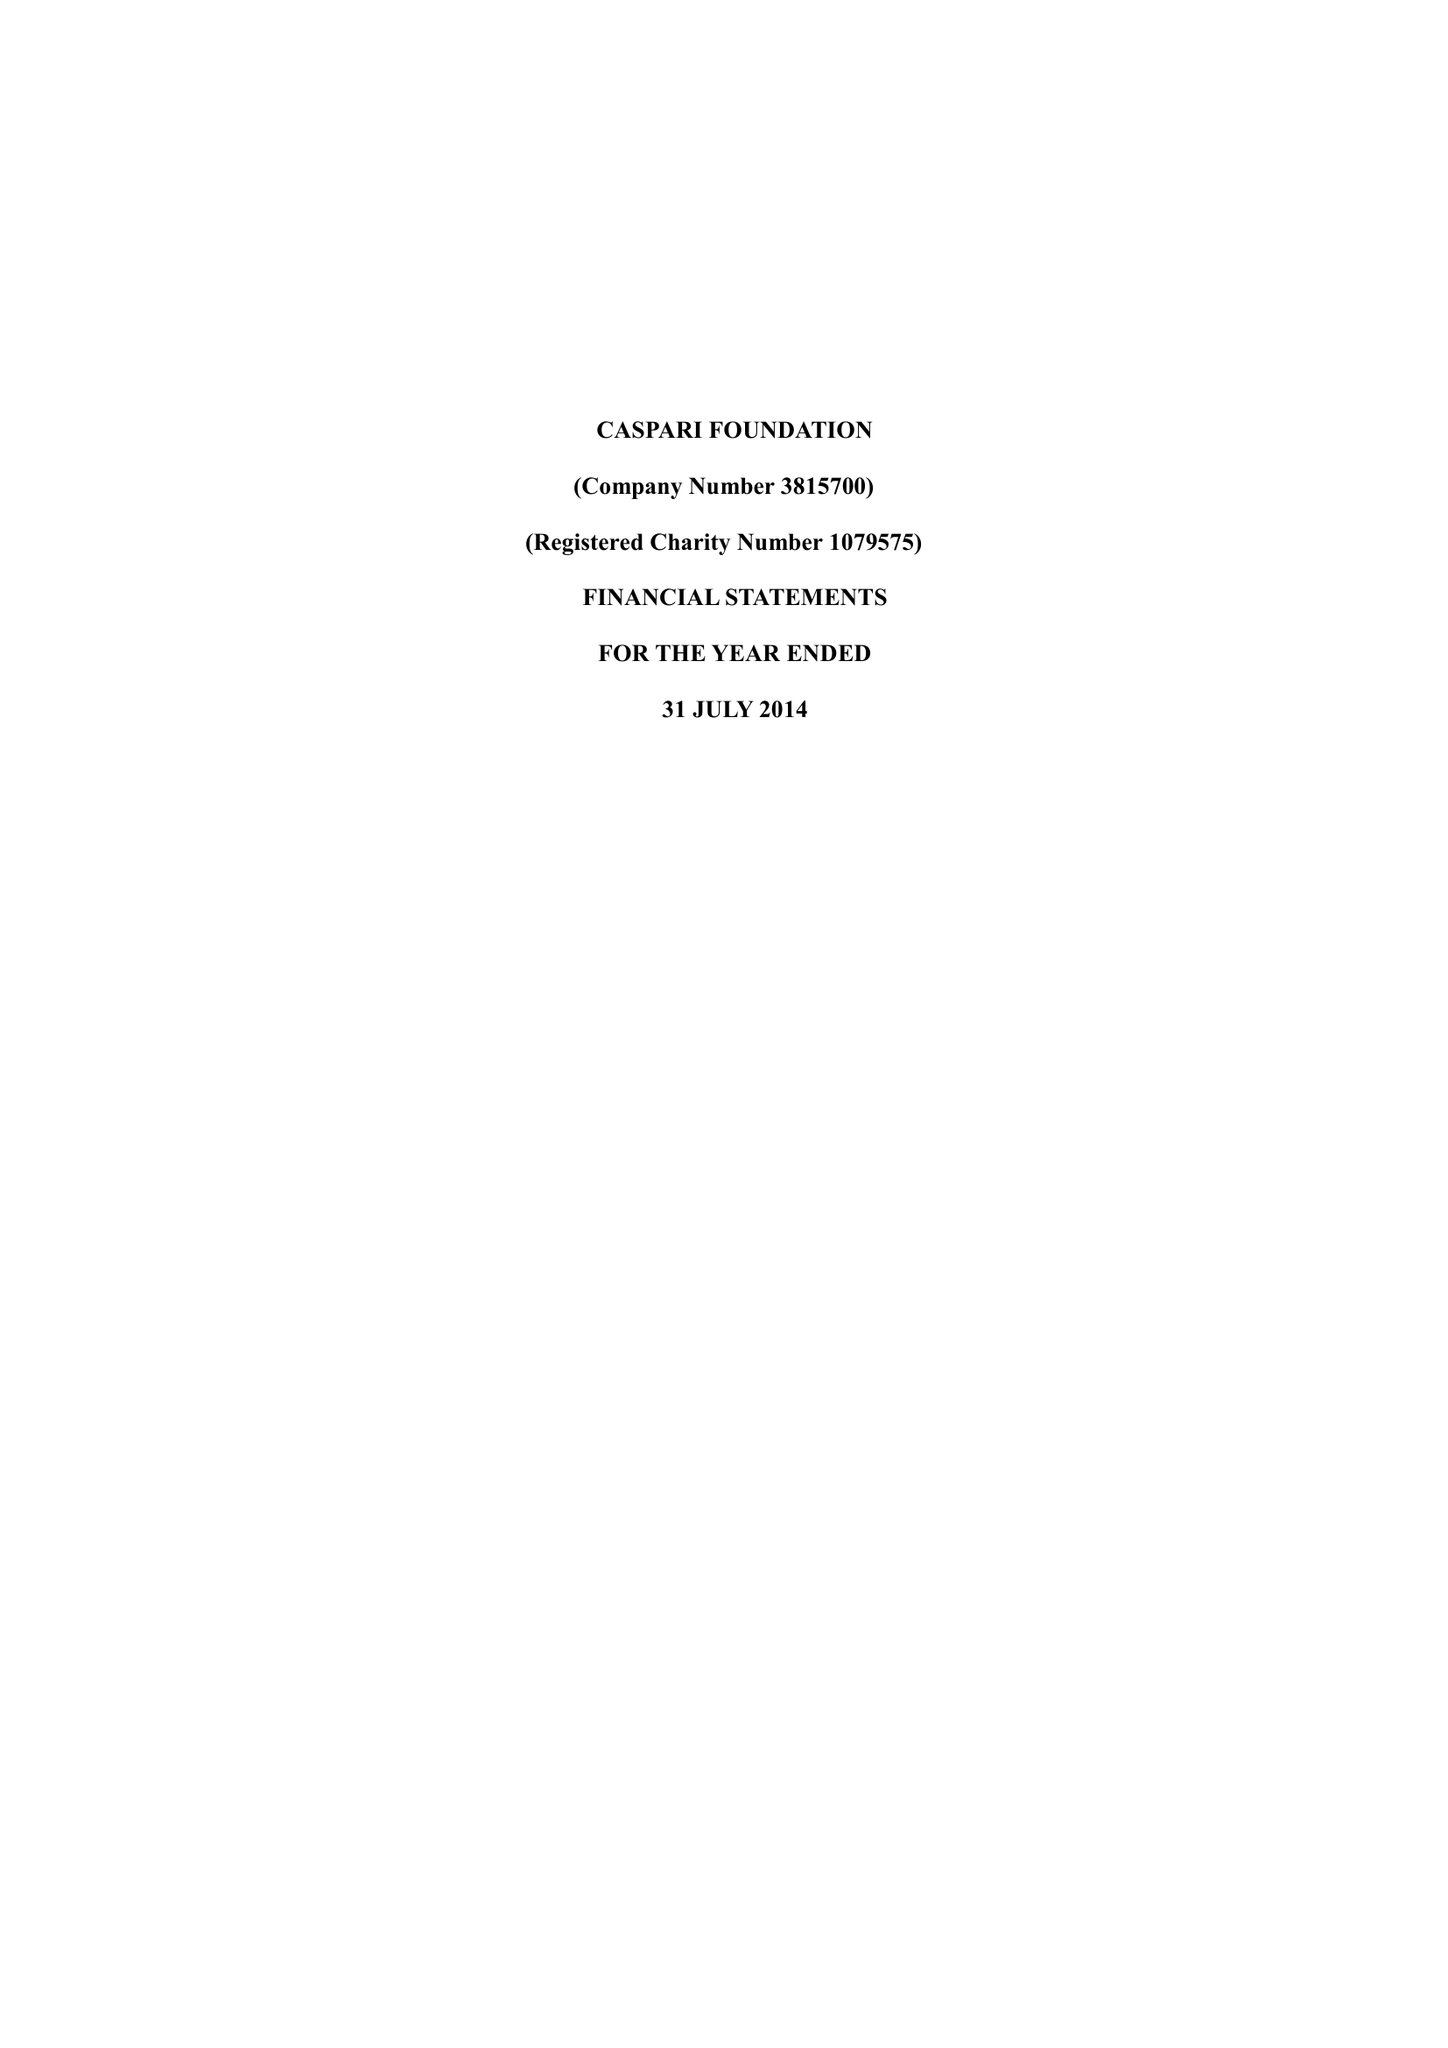What is the value for the report_date?
Answer the question using a single word or phrase. 2014-07-31 